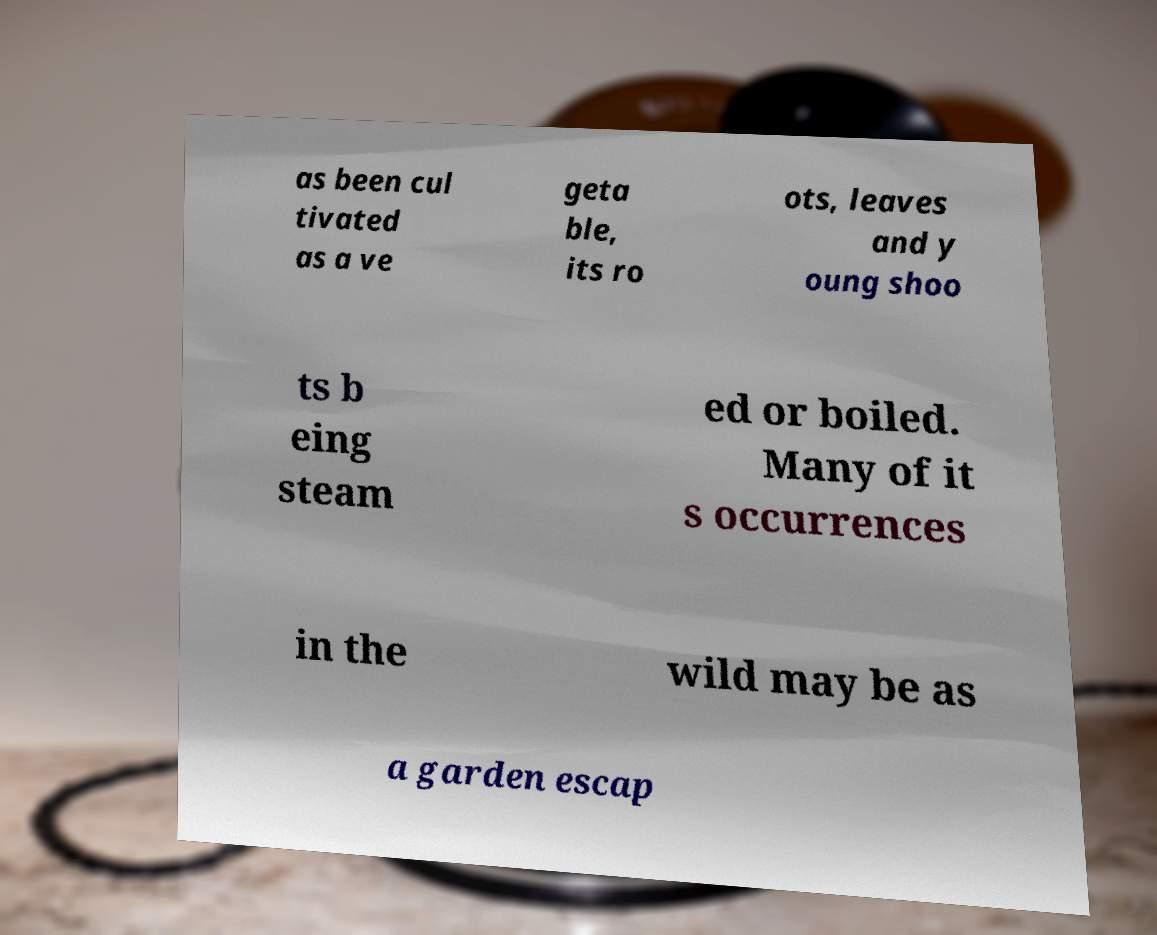I need the written content from this picture converted into text. Can you do that? as been cul tivated as a ve geta ble, its ro ots, leaves and y oung shoo ts b eing steam ed or boiled. Many of it s occurrences in the wild may be as a garden escap 